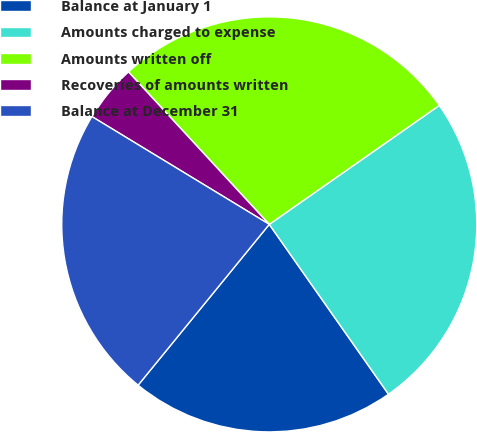Convert chart to OTSL. <chart><loc_0><loc_0><loc_500><loc_500><pie_chart><fcel>Balance at January 1<fcel>Amounts charged to expense<fcel>Amounts written off<fcel>Recoveries of amounts written<fcel>Balance at December 31<nl><fcel>20.63%<fcel>24.97%<fcel>27.15%<fcel>4.44%<fcel>22.8%<nl></chart> 